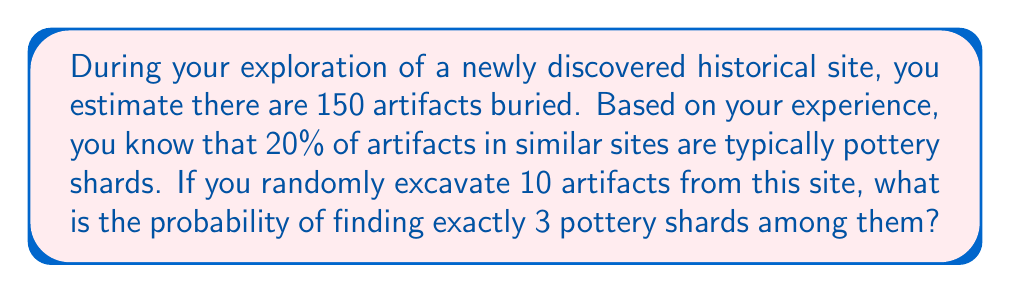Help me with this question. Let's approach this step-by-step using the binomial probability formula:

1) First, we need to identify the components of our problem:
   - Total number of artifacts: 150
   - Probability of an artifact being a pottery shard: 20% = 0.2
   - Number of artifacts excavated: 10
   - Number of pottery shards we want to find: 3

2) We can use the binomial probability formula:

   $$P(X = k) = \binom{n}{k} p^k (1-p)^{n-k}$$

   Where:
   $n$ = number of trials (artifacts excavated) = 10
   $k$ = number of successes (pottery shards) = 3
   $p$ = probability of success on each trial = 0.2

3) Let's calculate each part:

   a) $\binom{n}{k} = \binom{10}{3} = \frac{10!}{3!(10-3)!} = 120$

   b) $p^k = 0.2^3 = 0.008$

   c) $(1-p)^{n-k} = 0.8^7 = 0.2097152$

4) Now, let's put it all together:

   $$P(X = 3) = 120 \times 0.008 \times 0.2097152 = 0.201126592$$

5) Therefore, the probability of finding exactly 3 pottery shards when excavating 10 artifacts is approximately 0.2011 or 20.11%.
Answer: $0.2011$ or $20.11\%$ 